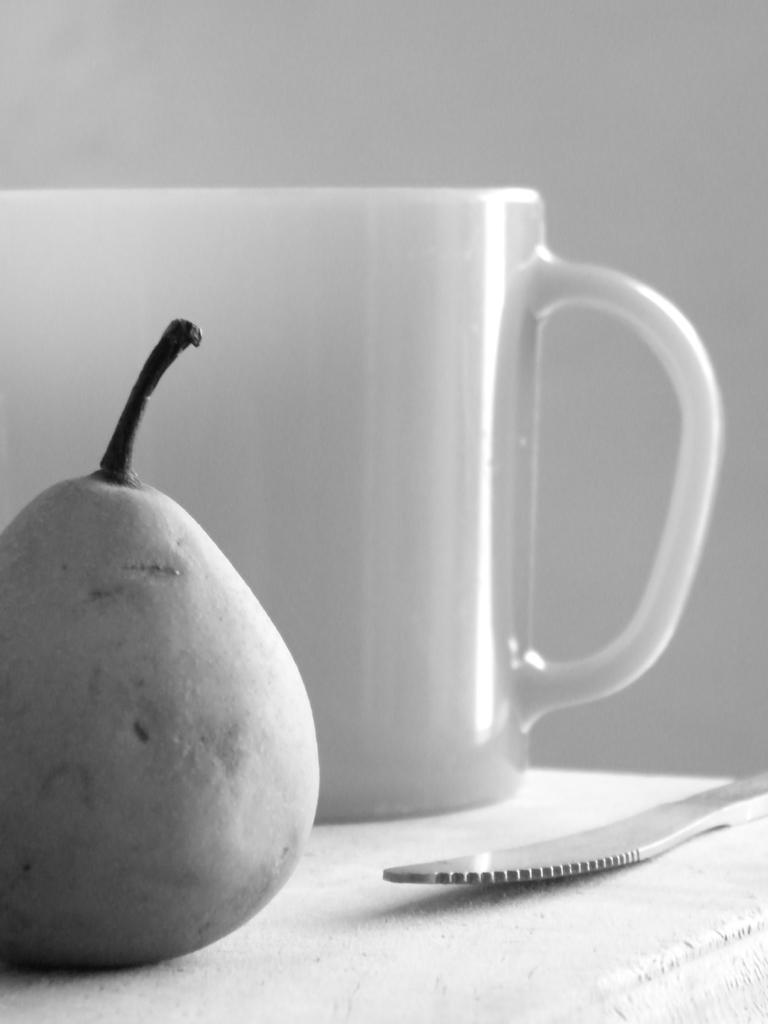Can you describe this image briefly? In this image we can see pearl, cup and knife placed on the table. 